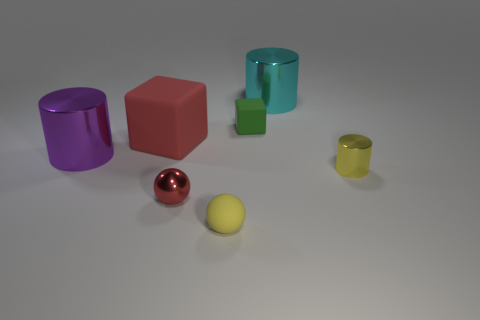There is a cyan metallic cylinder; is it the same size as the rubber block that is to the right of the large rubber cube?
Your answer should be very brief. No. What number of other objects are the same material as the small yellow cylinder?
Give a very brief answer. 3. Is there any other thing that is the same shape as the large purple thing?
Provide a succinct answer. Yes. There is a big cylinder on the right side of the small matte thing behind the large metal object in front of the large rubber object; what is its color?
Offer a terse response. Cyan. There is a metallic thing that is both to the left of the cyan metallic thing and in front of the purple shiny cylinder; what shape is it?
Give a very brief answer. Sphere. Is there any other thing that is the same size as the purple object?
Give a very brief answer. Yes. There is a matte object in front of the tiny shiny sphere behind the yellow matte ball; what is its color?
Give a very brief answer. Yellow. The big shiny thing that is to the right of the tiny thing to the left of the tiny thing in front of the red metal object is what shape?
Keep it short and to the point. Cylinder. There is a rubber object that is both right of the small red ball and behind the small red ball; how big is it?
Offer a terse response. Small. What number of tiny cylinders have the same color as the rubber ball?
Your answer should be very brief. 1. 